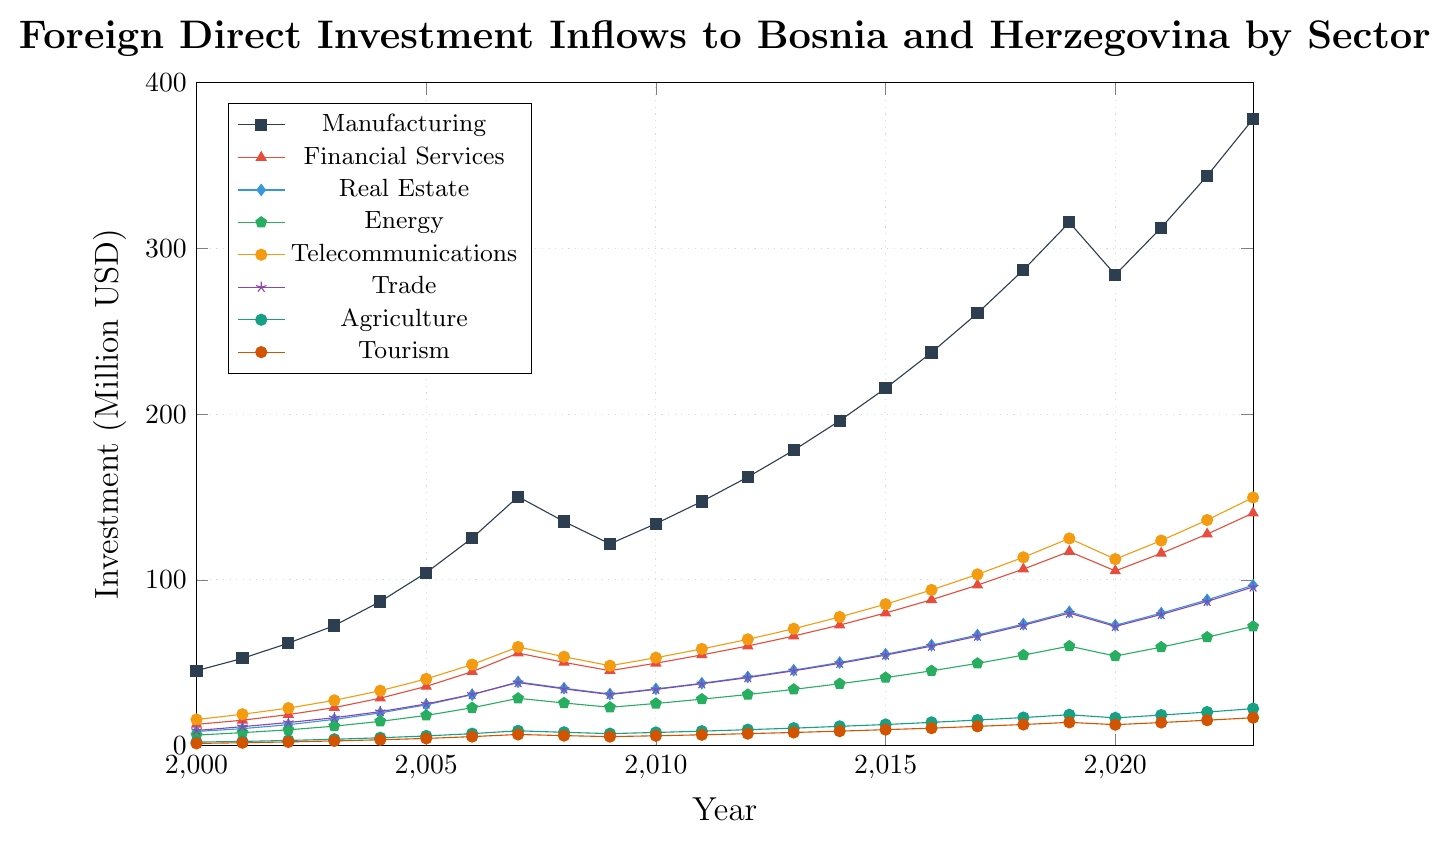Which sector saw the highest Foreign Direct Investment (FDI) inflows in 2023? The highest point in 2023 is observed for Manufacturing. By examining the line chart, we can determine that the Manufacturing line reaches the highest value, at 378.1 million USD.
Answer: Manufacturing In which year did the Real Estate sector reach 80.7 million USD in FDI inflows? Trace the line for Real Estate until it hits 80.7 on the y-axis. The corresponding year on the x-axis is 2019.
Answer: 2019 By how much did the FDI inflows in Telecommunications change from 2007 to 2008? Locate the values for Telecommunications in 2007 (59.5 million USD) and 2008 (53.6 million USD). The difference is calculated by 59.5 - 53.6 = 5.9 million USD.
Answer: 5.9 million USD How many sectors had FDI inflows exceeding 50 million USD in 2019? Identify each sector in 2019 and compare their values to 50 million. The sectors exceeding this threshold are Manufacturing, Financial Services, Real Estate, Energy, Telecommunications, and Trade. There are 6 sectors in total.
Answer: 6 Which sector had the lowest FDI inflows in 2015, and what was the value? By identifying the sector with the lowest point in 2015, we find that Tourism had the lowest FDI inflows at 9.6 million USD.
Answer: Tourism, 9.6 million USD What is the difference between the FDI inflows in Manufacturing and Agriculture in 2003? From the chart, find the values for Manufacturing (72.4 million USD) and Agriculture (3.8 million USD). The difference is 72.4 - 3.8 = 68.6 million USD.
Answer: 68.6 million USD Which sector had a more significant increase in FDI inflows from 2021 to 2022: Energy or Financial Services? Compare the change in values for Energy (59.4 to 65.4 million USD, a 6.0 increase) and Financial Services (116.0 to 127.6 million USD, an 11.6 increase). Financial Services had the larger increase.
Answer: Financial Services In which year did the combined FDI inflows for Financial Services and Real Estate first exceed 50 million USD? By summing up the values for both sectors across the years and identifying the first year the sum exceeds 50 million USD, we see that in 2004 (28.6 for Financial Services + 19.7 for Real Estate = 48.3) and in 2005 (35.7 + 24.6 = 60.3), so the year is 2005.
Answer: 2005 What is the average FDI inflow for Trade from 2010 to 2015? Sum the values for Trade from 2010 (33.9), 2011 (37.3), 2012 (41.0), 2013 (45.1), 2014 (49.6), and 2015 (54.6) which equals 261.5. Divide by 6 years, resulting in 261.5 / 6 ≈ 43.58 million USD.
Answer: 43.58 million USD 